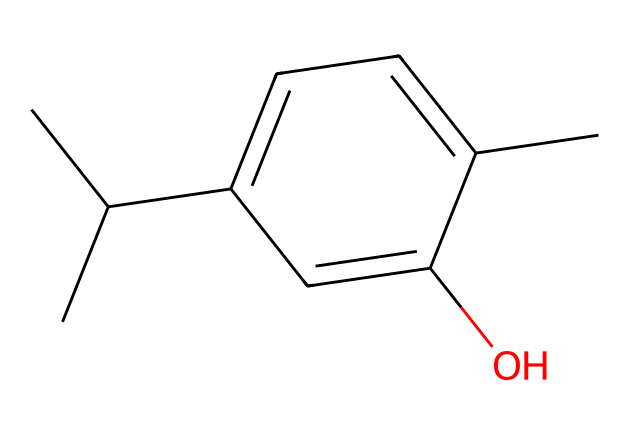What is the molecular formula of this chemical? To determine the molecular formula, we need to count the number of each type of atom in the structure represented by the SMILES. Upon deciphering the SMILES notation, we find there are 10 carbon atoms, 14 hydrogen atoms, and 1 oxygen atom, which leads to the molecular formula C10H14O.
Answer: C10H14O How many rings are present in the structure? By examining the chemical structure provided by the SMILES, we identify one cyclohexene ring in the compound, as represented by the 'C1=C' notation, indicating that a carbon atom is part of a ring. Thus, there is 1 ring present.
Answer: 1 What type of compound is thymol classified as? The SMILES structure indicates multiple carbon atoms bonded in a specific arrangement that signifies it's a terpene. Given its natural origin from thyme oil, it's specifically classified as a phenolic compound due to the presence of the hydroxyl (–OH) group directly attached to a benzene ring.
Answer: phenolic Which functional group is present in this molecule? Analyzing the structure, we can identify the –OH group attached to the carbon ring, which is indicative of an alcohol functional group. This functional group is characteristic of phenolic compounds and contributes to thymol's properties as a pesticide.
Answer: alcohol How many hydrogen atoms are directly bonded to the benzene-like ring? To determine the number of hydrogen atoms bonded to the aromatic ring, we look closely at the structure outline provided by the SMILES. The structure reveals that there are six carbon atoms connected in a cyclic fashion, with some carbons having hydroxyl groups or alkyl groups, leading to a total of 6 directly bonded hydrogen atoms to the ring.
Answer: 6 Which aspect of thymol contributes to its function as a pesticide? The presence of the hydroxyl (–OH) group in the molecular structure enhances thymol's solubility and reactivity, allowing it to effectively target and disrupt the biological processes of pests. This functional group is essential for its antibacterial and antifungal activities, therefore contributing to its role as a natural pesticide.
Answer: hydroxyl group 